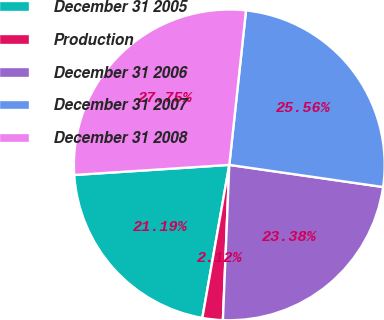Convert chart to OTSL. <chart><loc_0><loc_0><loc_500><loc_500><pie_chart><fcel>December 31 2005<fcel>Production<fcel>December 31 2006<fcel>December 31 2007<fcel>December 31 2008<nl><fcel>21.19%<fcel>2.12%<fcel>23.38%<fcel>25.56%<fcel>27.75%<nl></chart> 